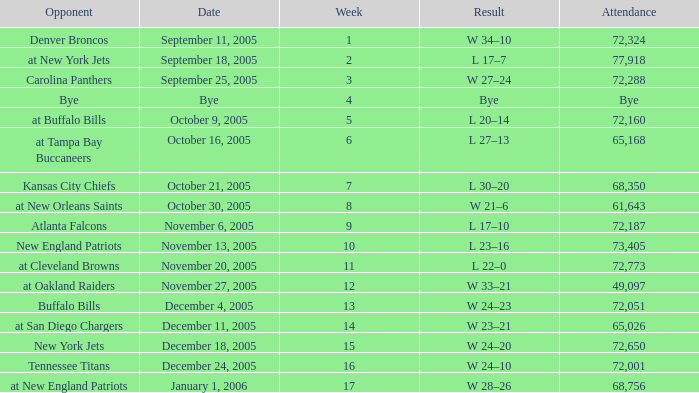What is the Date of the game with an attendance of 72,051 after Week 9? December 4, 2005. 